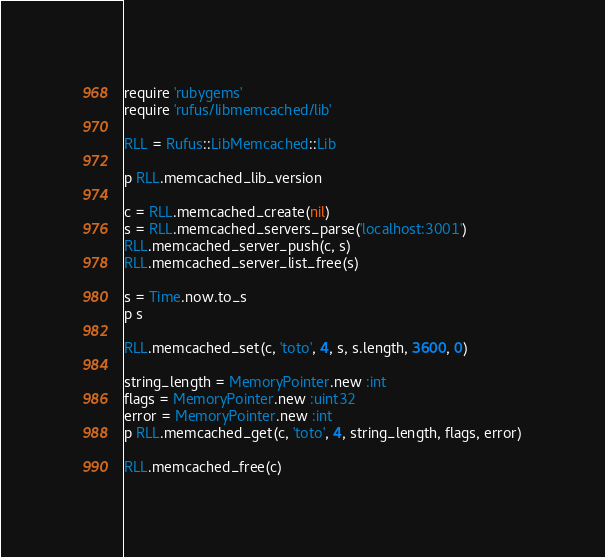<code> <loc_0><loc_0><loc_500><loc_500><_Ruby_>
require 'rubygems'
require 'rufus/libmemcached/lib'

RLL = Rufus::LibMemcached::Lib

p RLL.memcached_lib_version

c = RLL.memcached_create(nil)
s = RLL.memcached_servers_parse('localhost:3001')
RLL.memcached_server_push(c, s)
RLL.memcached_server_list_free(s)

s = Time.now.to_s
p s

RLL.memcached_set(c, 'toto', 4, s, s.length, 3600, 0)

string_length = MemoryPointer.new :int
flags = MemoryPointer.new :uint32
error = MemoryPointer.new :int
p RLL.memcached_get(c, 'toto', 4, string_length, flags, error)

RLL.memcached_free(c)

</code> 